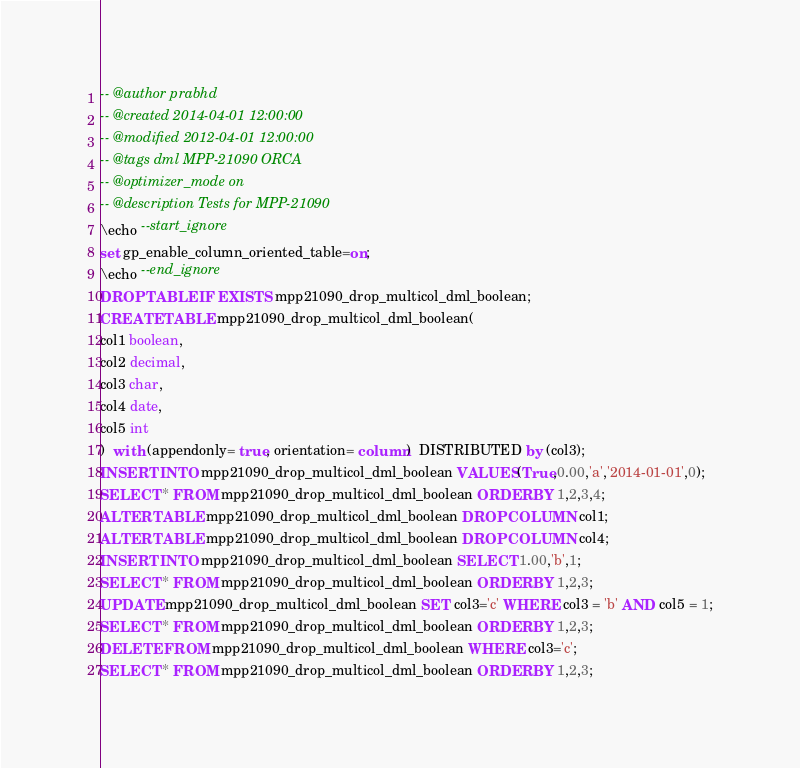Convert code to text. <code><loc_0><loc_0><loc_500><loc_500><_SQL_>-- @author prabhd 
-- @created 2014-04-01 12:00:00
-- @modified 2012-04-01 12:00:00
-- @tags dml MPP-21090 ORCA
-- @optimizer_mode on	
-- @description Tests for MPP-21090
\echo --start_ignore
set gp_enable_column_oriented_table=on;
\echo --end_ignore
DROP TABLE IF EXISTS mpp21090_drop_multicol_dml_boolean;
CREATE TABLE mpp21090_drop_multicol_dml_boolean(
col1 boolean,
col2 decimal,
col3 char,
col4 date,
col5 int
)  with (appendonly= true, orientation= column)  DISTRIBUTED by (col3);
INSERT INTO mpp21090_drop_multicol_dml_boolean VALUES(True,0.00,'a','2014-01-01',0);
SELECT * FROM mpp21090_drop_multicol_dml_boolean ORDER BY 1,2,3,4;
ALTER TABLE mpp21090_drop_multicol_dml_boolean DROP COLUMN col1;
ALTER TABLE mpp21090_drop_multicol_dml_boolean DROP COLUMN col4;
INSERT INTO mpp21090_drop_multicol_dml_boolean SELECT 1.00,'b',1;
SELECT * FROM mpp21090_drop_multicol_dml_boolean ORDER BY 1,2,3;
UPDATE mpp21090_drop_multicol_dml_boolean SET col3='c' WHERE col3 = 'b' AND col5 = 1;
SELECT * FROM mpp21090_drop_multicol_dml_boolean ORDER BY 1,2,3;
DELETE FROM mpp21090_drop_multicol_dml_boolean WHERE col3='c';
SELECT * FROM mpp21090_drop_multicol_dml_boolean ORDER BY 1,2,3;

</code> 